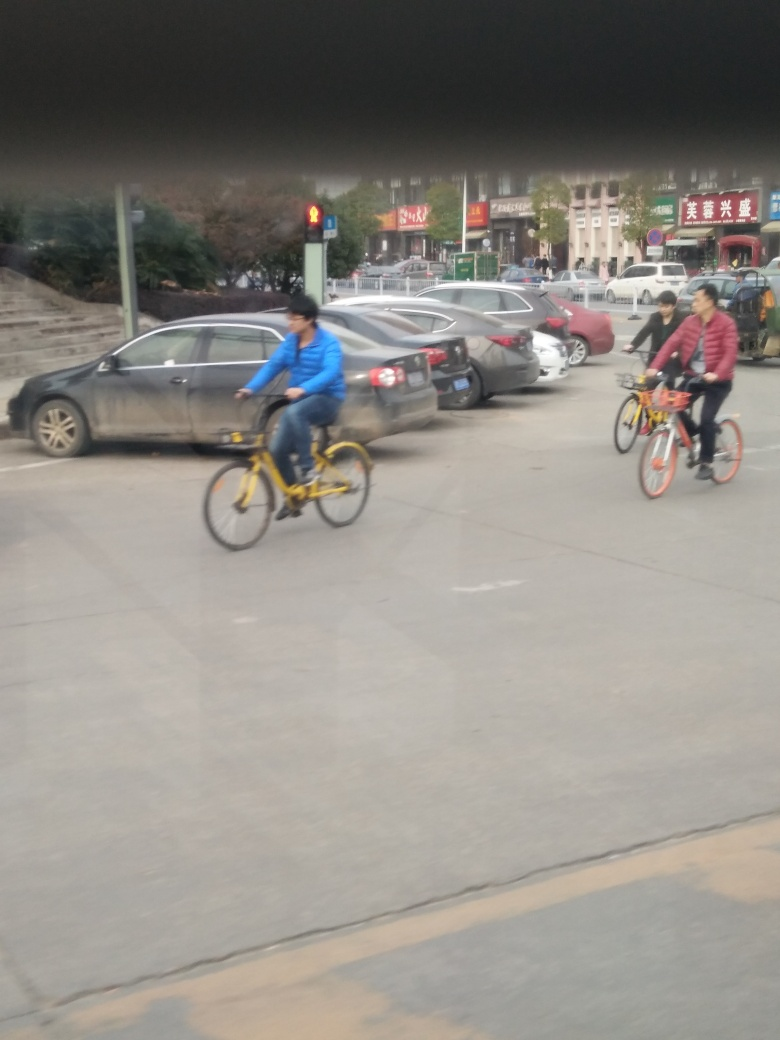What is the condition of the cars parked on the side of the street? The cars on the side of the street are stationary and appear to be parked in an orderly manner. Some vehicles show dirt or water stains, indicating they haven't been cleaned recently. There is no visible damage to the cars in the image. 